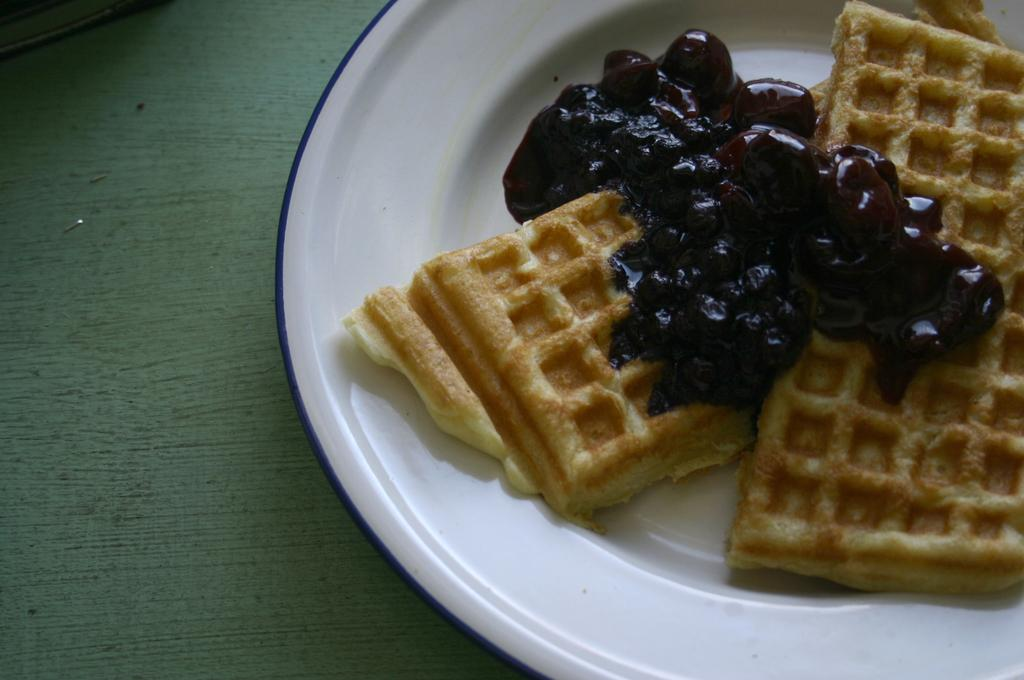What can be seen on the plate in the image? There is food present on the plate in the image. Can you describe the plate in more detail? Unfortunately, the facts provided do not give any additional details about the plate. How many maids are attending to the chickens in the image? There are no maids or chickens present in the image. 